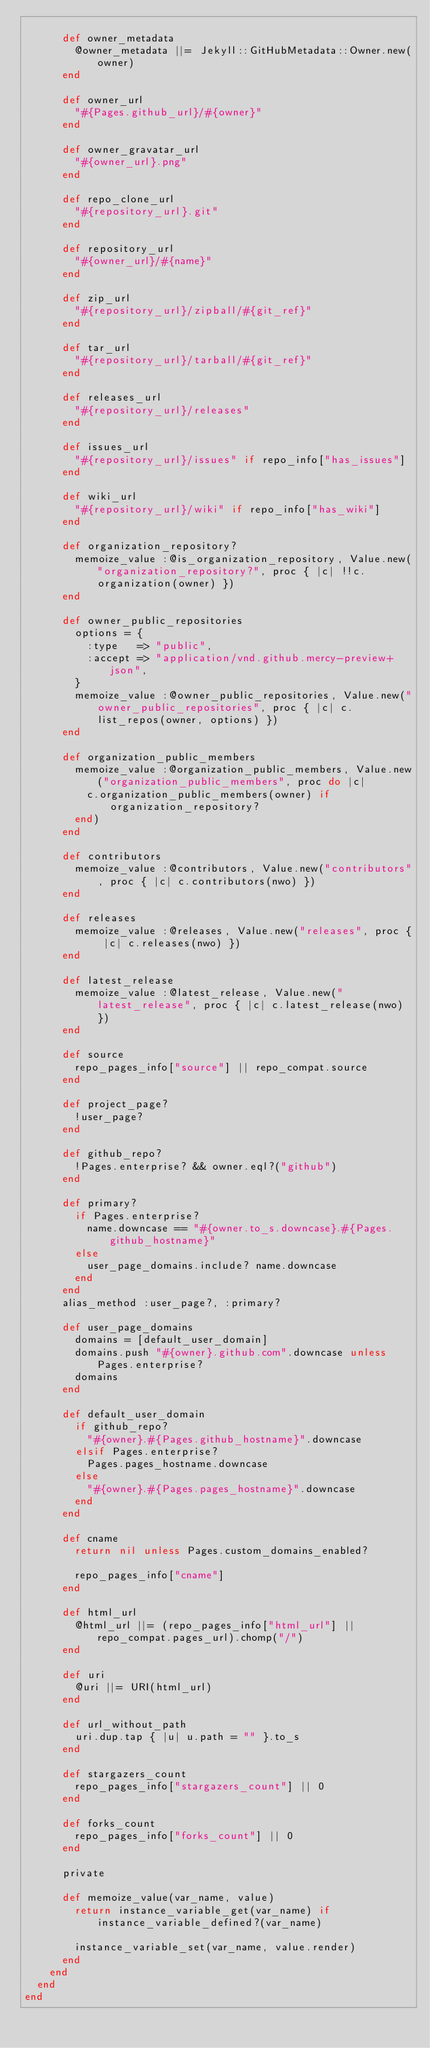Convert code to text. <code><loc_0><loc_0><loc_500><loc_500><_Ruby_>
      def owner_metadata
        @owner_metadata ||= Jekyll::GitHubMetadata::Owner.new(owner)
      end

      def owner_url
        "#{Pages.github_url}/#{owner}"
      end

      def owner_gravatar_url
        "#{owner_url}.png"
      end

      def repo_clone_url
        "#{repository_url}.git"
      end

      def repository_url
        "#{owner_url}/#{name}"
      end

      def zip_url
        "#{repository_url}/zipball/#{git_ref}"
      end

      def tar_url
        "#{repository_url}/tarball/#{git_ref}"
      end

      def releases_url
        "#{repository_url}/releases"
      end

      def issues_url
        "#{repository_url}/issues" if repo_info["has_issues"]
      end

      def wiki_url
        "#{repository_url}/wiki" if repo_info["has_wiki"]
      end

      def organization_repository?
        memoize_value :@is_organization_repository, Value.new("organization_repository?", proc { |c| !!c.organization(owner) })
      end

      def owner_public_repositories
        options = {
          :type   => "public",
          :accept => "application/vnd.github.mercy-preview+json",
        }
        memoize_value :@owner_public_repositories, Value.new("owner_public_repositories", proc { |c| c.list_repos(owner, options) })
      end

      def organization_public_members
        memoize_value :@organization_public_members, Value.new("organization_public_members", proc do |c|
          c.organization_public_members(owner) if organization_repository?
        end)
      end

      def contributors
        memoize_value :@contributors, Value.new("contributors", proc { |c| c.contributors(nwo) })
      end

      def releases
        memoize_value :@releases, Value.new("releases", proc { |c| c.releases(nwo) })
      end

      def latest_release
        memoize_value :@latest_release, Value.new("latest_release", proc { |c| c.latest_release(nwo) })
      end

      def source
        repo_pages_info["source"] || repo_compat.source
      end

      def project_page?
        !user_page?
      end

      def github_repo?
        !Pages.enterprise? && owner.eql?("github")
      end

      def primary?
        if Pages.enterprise?
          name.downcase == "#{owner.to_s.downcase}.#{Pages.github_hostname}"
        else
          user_page_domains.include? name.downcase
        end
      end
      alias_method :user_page?, :primary?

      def user_page_domains
        domains = [default_user_domain]
        domains.push "#{owner}.github.com".downcase unless Pages.enterprise?
        domains
      end

      def default_user_domain
        if github_repo?
          "#{owner}.#{Pages.github_hostname}".downcase
        elsif Pages.enterprise?
          Pages.pages_hostname.downcase
        else
          "#{owner}.#{Pages.pages_hostname}".downcase
        end
      end

      def cname
        return nil unless Pages.custom_domains_enabled?

        repo_pages_info["cname"]
      end

      def html_url
        @html_url ||= (repo_pages_info["html_url"] || repo_compat.pages_url).chomp("/")
      end

      def uri
        @uri ||= URI(html_url)
      end

      def url_without_path
        uri.dup.tap { |u| u.path = "" }.to_s
      end

      def stargazers_count
        repo_pages_info["stargazers_count"] || 0
      end

      def forks_count
        repo_pages_info["forks_count"] || 0
      end

      private

      def memoize_value(var_name, value)
        return instance_variable_get(var_name) if instance_variable_defined?(var_name)

        instance_variable_set(var_name, value.render)
      end
    end
  end
end
</code> 